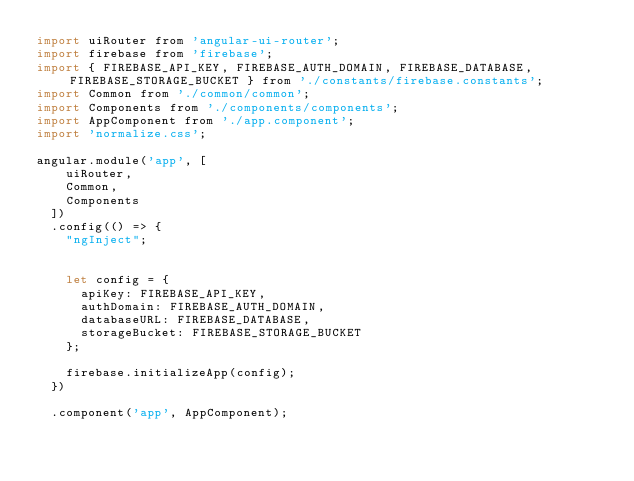Convert code to text. <code><loc_0><loc_0><loc_500><loc_500><_JavaScript_>import uiRouter from 'angular-ui-router';
import firebase from 'firebase';
import { FIREBASE_API_KEY, FIREBASE_AUTH_DOMAIN, FIREBASE_DATABASE, FIREBASE_STORAGE_BUCKET } from './constants/firebase.constants';
import Common from './common/common';
import Components from './components/components';
import AppComponent from './app.component';
import 'normalize.css';

angular.module('app', [
    uiRouter,
    Common,
    Components
  ])
  .config(() => {
    "ngInject";


    let config = {
      apiKey: FIREBASE_API_KEY,
      authDomain: FIREBASE_AUTH_DOMAIN,
      databaseURL: FIREBASE_DATABASE,
      storageBucket: FIREBASE_STORAGE_BUCKET
    };

    firebase.initializeApp(config);
  })

  .component('app', AppComponent);
</code> 